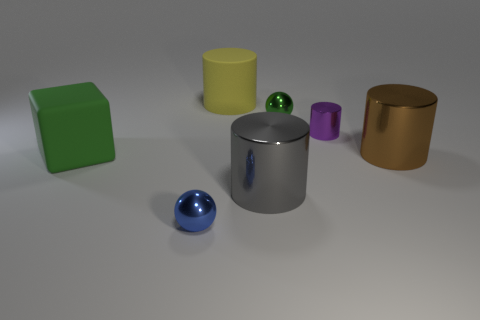Add 1 gray objects. How many objects exist? 8 Subtract all spheres. How many objects are left? 5 Add 6 large cyan metal cylinders. How many large cyan metal cylinders exist? 6 Subtract 1 blue spheres. How many objects are left? 6 Subtract all green rubber cubes. Subtract all large green things. How many objects are left? 5 Add 1 green shiny objects. How many green shiny objects are left? 2 